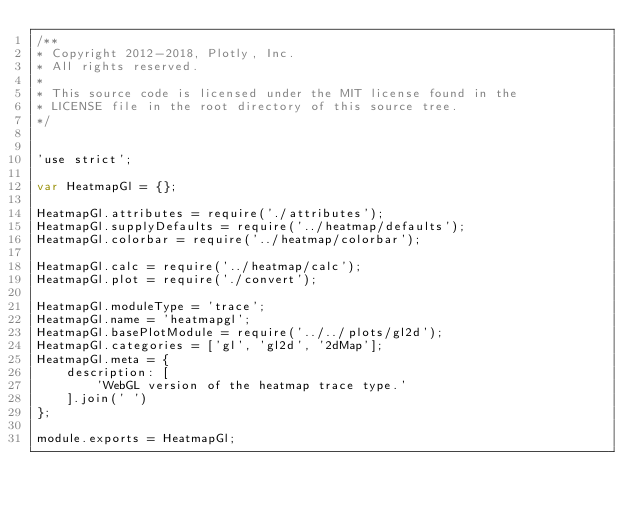Convert code to text. <code><loc_0><loc_0><loc_500><loc_500><_JavaScript_>/**
* Copyright 2012-2018, Plotly, Inc.
* All rights reserved.
*
* This source code is licensed under the MIT license found in the
* LICENSE file in the root directory of this source tree.
*/


'use strict';

var HeatmapGl = {};

HeatmapGl.attributes = require('./attributes');
HeatmapGl.supplyDefaults = require('../heatmap/defaults');
HeatmapGl.colorbar = require('../heatmap/colorbar');

HeatmapGl.calc = require('../heatmap/calc');
HeatmapGl.plot = require('./convert');

HeatmapGl.moduleType = 'trace';
HeatmapGl.name = 'heatmapgl';
HeatmapGl.basePlotModule = require('../../plots/gl2d');
HeatmapGl.categories = ['gl', 'gl2d', '2dMap'];
HeatmapGl.meta = {
    description: [
        'WebGL version of the heatmap trace type.'
    ].join(' ')
};

module.exports = HeatmapGl;
</code> 